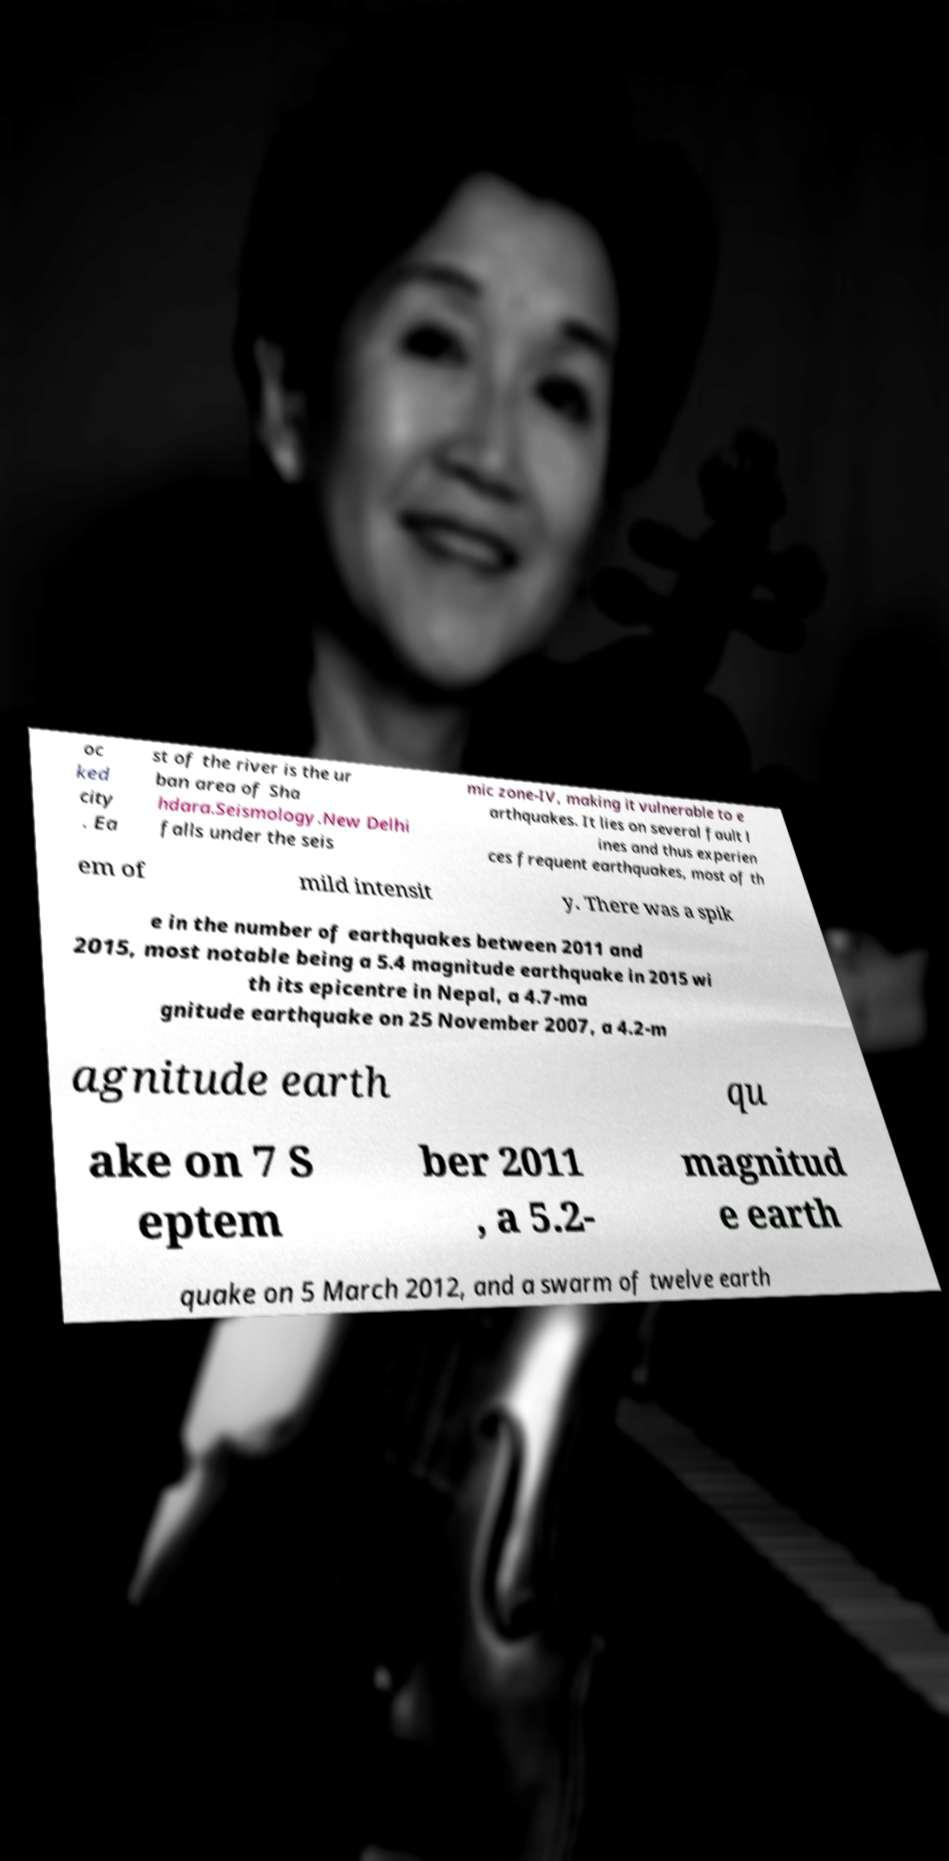Please identify and transcribe the text found in this image. oc ked city . Ea st of the river is the ur ban area of Sha hdara.Seismology.New Delhi falls under the seis mic zone-IV, making it vulnerable to e arthquakes. It lies on several fault l ines and thus experien ces frequent earthquakes, most of th em of mild intensit y. There was a spik e in the number of earthquakes between 2011 and 2015, most notable being a 5.4 magnitude earthquake in 2015 wi th its epicentre in Nepal, a 4.7-ma gnitude earthquake on 25 November 2007, a 4.2-m agnitude earth qu ake on 7 S eptem ber 2011 , a 5.2- magnitud e earth quake on 5 March 2012, and a swarm of twelve earth 